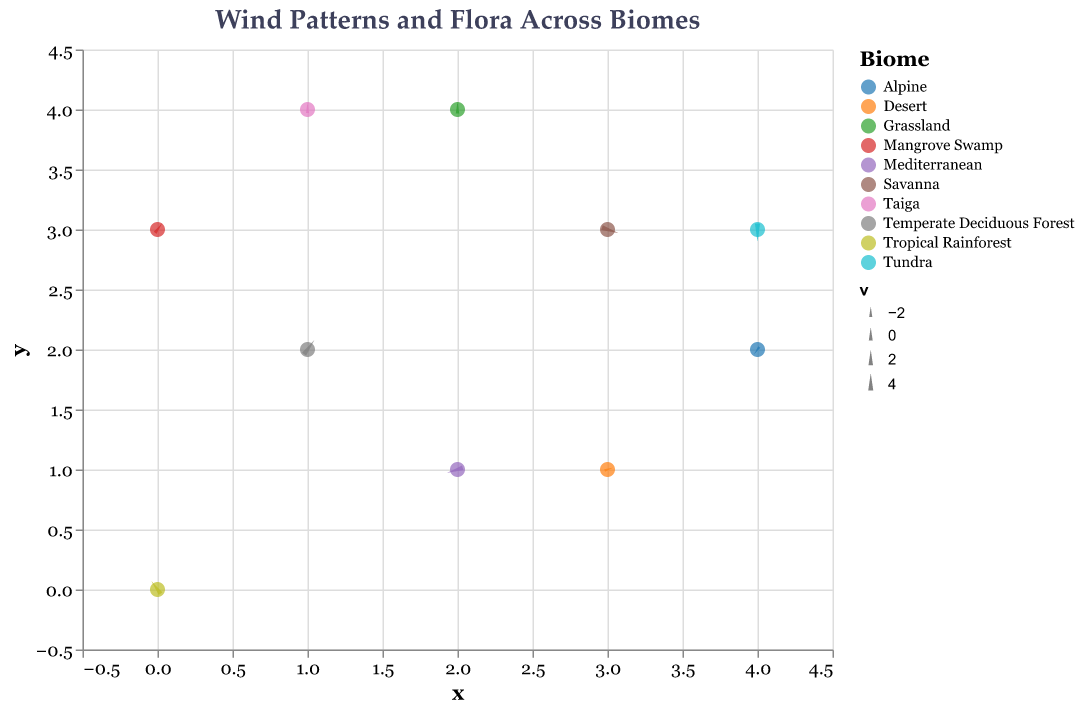What is the title of the figure? Look at the text displayed at the top of the figure to find the title.
Answer: Wind Patterns and Flora Across Biomes How many different biomes are represented? Count the unique biome labels in the legend on the right. There are ten unique biomes.
Answer: 10 Which biome at coordinates (1, 4) has a vector pointing southwest? Identify the data point at (1, 4) and observe the wind direction vector pointing southwest. The associated biome is Taiga.
Answer: Taiga What direction is the wind vector for the biome "Mediterranean"? Find the data point labeled "Mediterranean" at (2, 1) and observe the direction of the vector, which points northeast.
Answer: Northeast Which biomes have wind vectors with both negative u and v components? Identify data points where both u and v are negative, which are "Desert" at (3, 1) and "Taiga" at (1, 4).
Answer: Desert and Taiga Which flora is associated with the biome experiencing the strongest northward wind vector? Look for the highest positive v value, which corresponds to "Savanna" at coordinates (3, 3) with flora "Acacia Trees".
Answer: Acacia Trees Are there any biomes where the wind is primarily blowing to the east? Check for biomes where u is significantly positive and v is either positive or negative, such as "Tropical Rainforest" at (0, 0) and "Grassland" at (2, 4).
Answer: Tropical Rainforest and Grassland What is the average length of the wind vectors in the "Savanna" and "Tundra" biomes? Calculate the magnitude of the wind vectors for Savanna (u=-1, v=4) and Tundra (u=1, v=5). The magnitudes are sqrt((-1)^2 + 4^2) ≈ 4.12 and sqrt(1^2 + 5^2) ≈ 5.10, with an average of (4.12 + 5.10) / 2 ≈ 4.61.
Answer: 4.61 Which biome has the shortest wind vector? Calculate the magnitudes for all vectors and find that "Mangrove Swamp" at (0, 3) with vector (-3, -1) has the shortest length: sqrt((-3)^2 + (-1)^2) ≈ 3.16.
Answer: Mangrove Swamp How does the wind vector in the "Temperate Deciduous Forest" compare to the one in the "Mediterranean"? Compare vectors (u=-3, v=4) at (1, 2) for "Temperate Deciduous Forest" and (u=3, v=3) at (2, 1) for "Mediterranean". Note that "Temperate Deciduous Forest" vector is northwest, while "Mediterranean" is northeast.
Answer: Different directions 